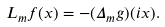Convert formula to latex. <formula><loc_0><loc_0><loc_500><loc_500>L _ { m } f ( x ) = - ( \Delta _ { m } g ) ( i x ) .</formula> 